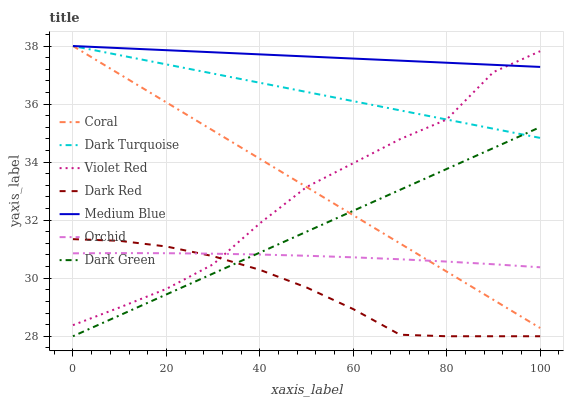Does Dark Red have the minimum area under the curve?
Answer yes or no. Yes. Does Medium Blue have the maximum area under the curve?
Answer yes or no. Yes. Does Dark Turquoise have the minimum area under the curve?
Answer yes or no. No. Does Dark Turquoise have the maximum area under the curve?
Answer yes or no. No. Is Dark Turquoise the smoothest?
Answer yes or no. Yes. Is Violet Red the roughest?
Answer yes or no. Yes. Is Coral the smoothest?
Answer yes or no. No. Is Coral the roughest?
Answer yes or no. No. Does Dark Red have the lowest value?
Answer yes or no. Yes. Does Dark Turquoise have the lowest value?
Answer yes or no. No. Does Medium Blue have the highest value?
Answer yes or no. Yes. Does Dark Red have the highest value?
Answer yes or no. No. Is Dark Green less than Violet Red?
Answer yes or no. Yes. Is Medium Blue greater than Dark Green?
Answer yes or no. Yes. Does Violet Red intersect Coral?
Answer yes or no. Yes. Is Violet Red less than Coral?
Answer yes or no. No. Is Violet Red greater than Coral?
Answer yes or no. No. Does Dark Green intersect Violet Red?
Answer yes or no. No. 